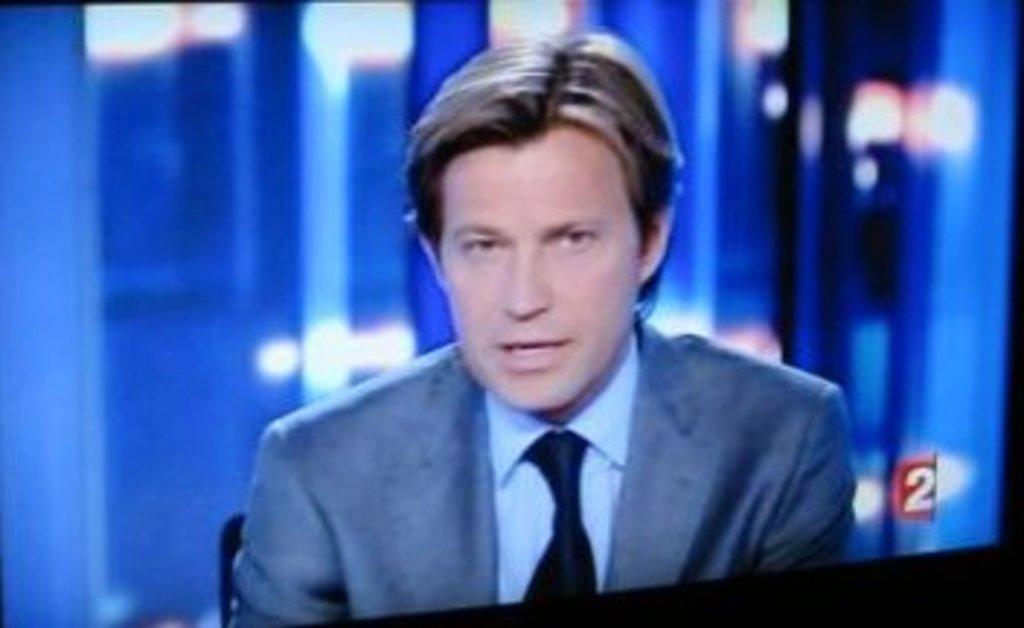What electronic device is present in the image? There is a television in the image. What can be seen on the television screen? A person is visible on the television screen. How would you describe the quality of the image on the television screen? The background on the television screen appears blurry. How many eggs are present in the park in the image? There are no eggs or park present in the image; it only features a television with a person on the screen. 